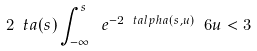Convert formula to latex. <formula><loc_0><loc_0><loc_500><loc_500>2 \ t a ( s ) \int _ { - \infty } ^ { s } \ e ^ { - 2 \ t a l p h a ( s , u ) } \ 6 u < 3</formula> 